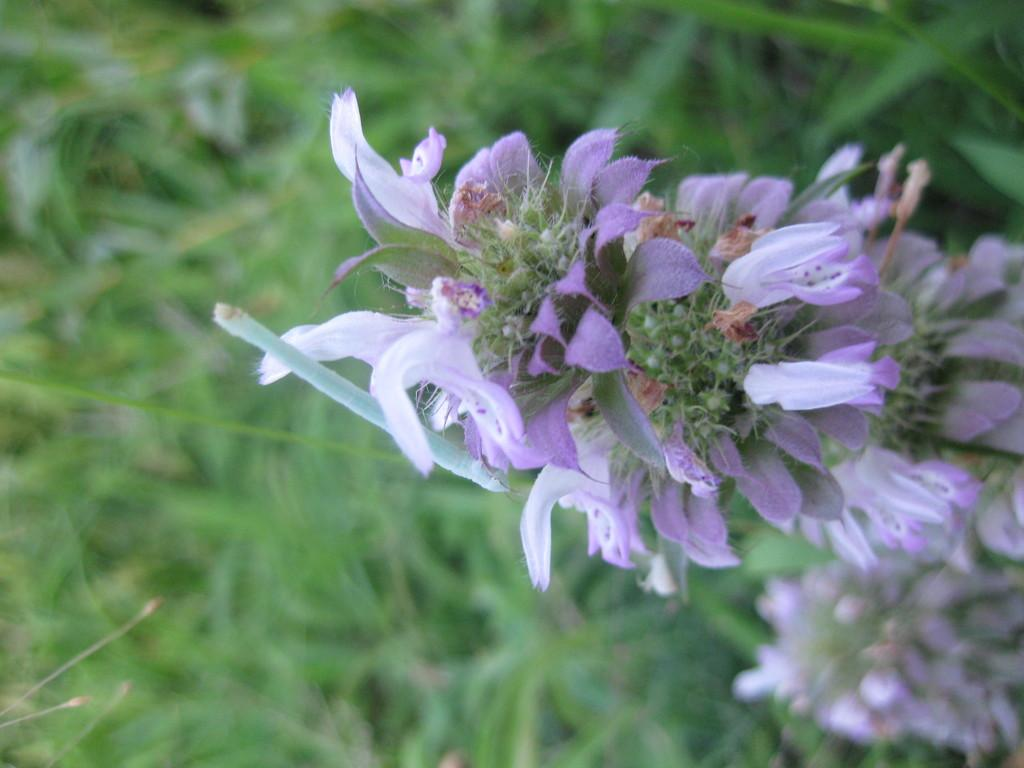What colors are the flowers in the image? The flowers in the image are white and violet. Can you describe the background of the image? The background is green and blurred. How many questions are hanging on the door in the image? A: There is no door or questions present in the image; it features flowers and a blurred green background. 